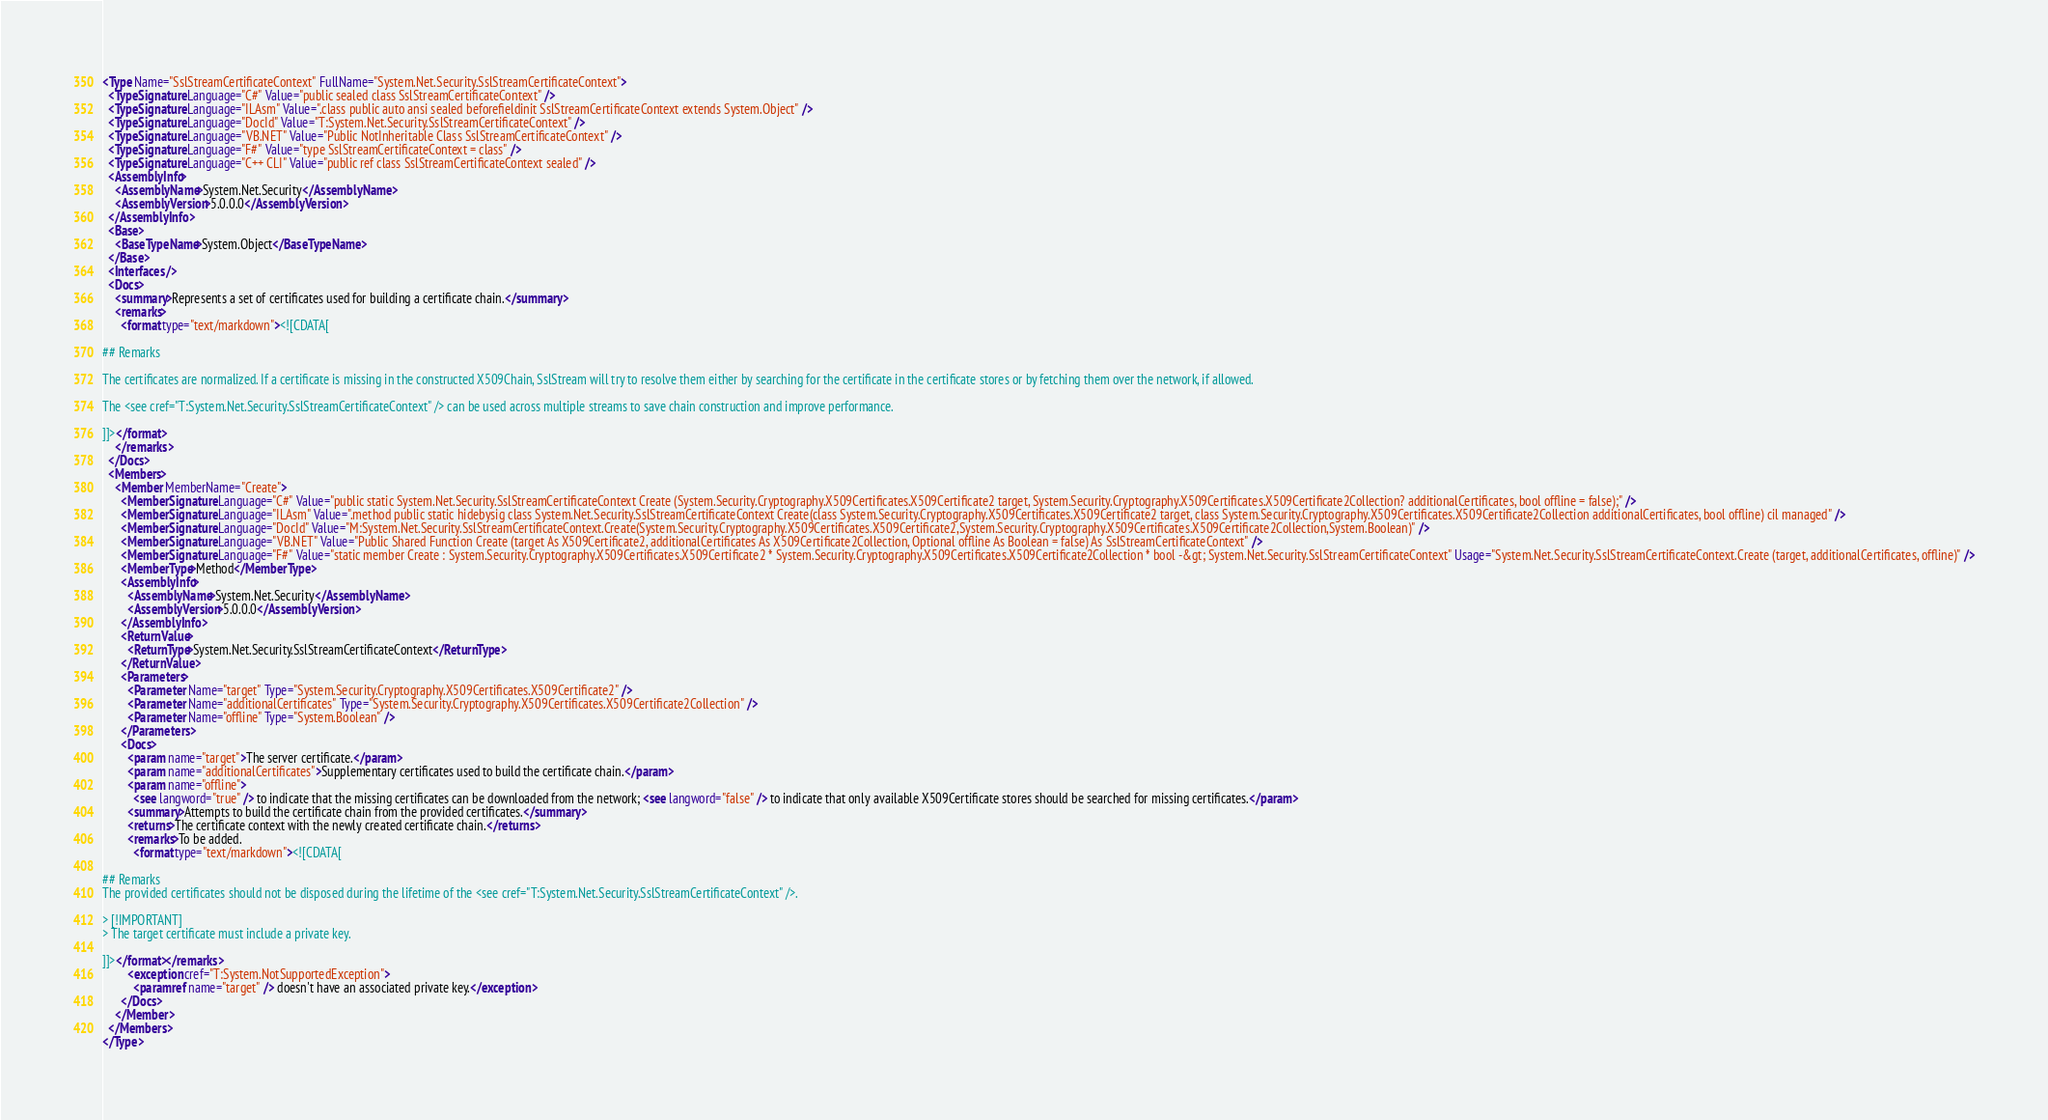<code> <loc_0><loc_0><loc_500><loc_500><_XML_><Type Name="SslStreamCertificateContext" FullName="System.Net.Security.SslStreamCertificateContext">
  <TypeSignature Language="C#" Value="public sealed class SslStreamCertificateContext" />
  <TypeSignature Language="ILAsm" Value=".class public auto ansi sealed beforefieldinit SslStreamCertificateContext extends System.Object" />
  <TypeSignature Language="DocId" Value="T:System.Net.Security.SslStreamCertificateContext" />
  <TypeSignature Language="VB.NET" Value="Public NotInheritable Class SslStreamCertificateContext" />
  <TypeSignature Language="F#" Value="type SslStreamCertificateContext = class" />
  <TypeSignature Language="C++ CLI" Value="public ref class SslStreamCertificateContext sealed" />
  <AssemblyInfo>
    <AssemblyName>System.Net.Security</AssemblyName>
    <AssemblyVersion>5.0.0.0</AssemblyVersion>
  </AssemblyInfo>
  <Base>
    <BaseTypeName>System.Object</BaseTypeName>
  </Base>
  <Interfaces />
  <Docs>
    <summary>Represents a set of certificates used for building a certificate chain.</summary>
    <remarks>
      <format type="text/markdown"><![CDATA[ 

## Remarks

The certificates are normalized. If a certificate is missing in the constructed X509Chain, SslStream will try to resolve them either by searching for the certificate in the certificate stores or by fetching them over the network, if allowed.

The <see cref="T:System.Net.Security.SslStreamCertificateContext" /> can be used across multiple streams to save chain construction and improve performance.

]]></format>
    </remarks>
  </Docs>
  <Members>
    <Member MemberName="Create">
      <MemberSignature Language="C#" Value="public static System.Net.Security.SslStreamCertificateContext Create (System.Security.Cryptography.X509Certificates.X509Certificate2 target, System.Security.Cryptography.X509Certificates.X509Certificate2Collection? additionalCertificates, bool offline = false);" />
      <MemberSignature Language="ILAsm" Value=".method public static hidebysig class System.Net.Security.SslStreamCertificateContext Create(class System.Security.Cryptography.X509Certificates.X509Certificate2 target, class System.Security.Cryptography.X509Certificates.X509Certificate2Collection additionalCertificates, bool offline) cil managed" />
      <MemberSignature Language="DocId" Value="M:System.Net.Security.SslStreamCertificateContext.Create(System.Security.Cryptography.X509Certificates.X509Certificate2,System.Security.Cryptography.X509Certificates.X509Certificate2Collection,System.Boolean)" />
      <MemberSignature Language="VB.NET" Value="Public Shared Function Create (target As X509Certificate2, additionalCertificates As X509Certificate2Collection, Optional offline As Boolean = false) As SslStreamCertificateContext" />
      <MemberSignature Language="F#" Value="static member Create : System.Security.Cryptography.X509Certificates.X509Certificate2 * System.Security.Cryptography.X509Certificates.X509Certificate2Collection * bool -&gt; System.Net.Security.SslStreamCertificateContext" Usage="System.Net.Security.SslStreamCertificateContext.Create (target, additionalCertificates, offline)" />
      <MemberType>Method</MemberType>
      <AssemblyInfo>
        <AssemblyName>System.Net.Security</AssemblyName>
        <AssemblyVersion>5.0.0.0</AssemblyVersion>
      </AssemblyInfo>
      <ReturnValue>
        <ReturnType>System.Net.Security.SslStreamCertificateContext</ReturnType>
      </ReturnValue>
      <Parameters>
        <Parameter Name="target" Type="System.Security.Cryptography.X509Certificates.X509Certificate2" />
        <Parameter Name="additionalCertificates" Type="System.Security.Cryptography.X509Certificates.X509Certificate2Collection" />
        <Parameter Name="offline" Type="System.Boolean" />
      </Parameters>
      <Docs>
        <param name="target">The server certificate.</param>
        <param name="additionalCertificates">Supplementary certificates used to build the certificate chain.</param>
        <param name="offline">
          <see langword="true" /> to indicate that the missing certificates can be downloaded from the network; <see langword="false" /> to indicate that only available X509Certificate stores should be searched for missing certificates.</param>
        <summary>Attempts to build the certificate chain from the provided certificates.</summary>
        <returns>The certificate context with the newly created certificate chain.</returns>
        <remarks>To be added.
          <format type="text/markdown"><![CDATA[ 

## Remarks
The provided certificates should not be disposed during the lifetime of the <see cref="T:System.Net.Security.SslStreamCertificateContext" />.

> [!IMPORTANT]
> The target certificate must include a private key.

]]></format></remarks>
        <exception cref="T:System.NotSupportedException">
          <paramref name="target" /> doesn't have an associated private key.</exception>
      </Docs>
    </Member>
  </Members>
</Type>
</code> 